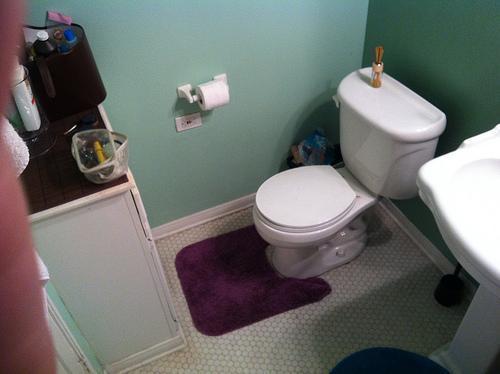How many toilet rolls are pictured?
Give a very brief answer. 1. 